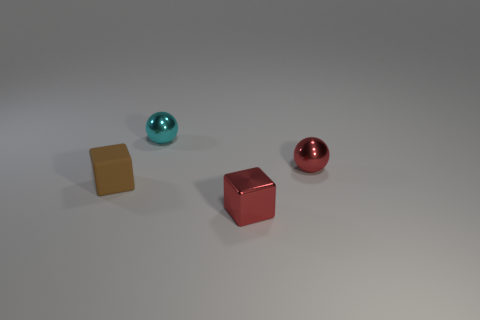Add 3 small cyan shiny things. How many objects exist? 7 Add 4 cyan spheres. How many cyan spheres exist? 5 Subtract 1 red cubes. How many objects are left? 3 Subtract all tiny metal objects. Subtract all purple shiny cylinders. How many objects are left? 1 Add 1 tiny brown cubes. How many tiny brown cubes are left? 2 